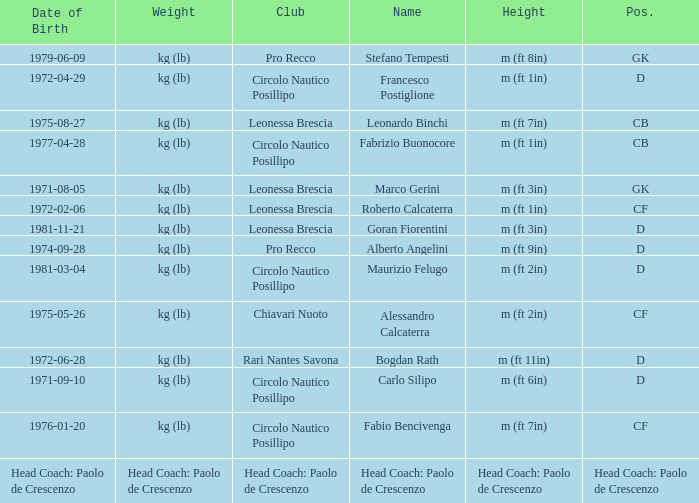What is the name of the player from club Circolo Nautico Posillipo and a position of D? Francesco Postiglione, Maurizio Felugo, Carlo Silipo. 